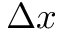<formula> <loc_0><loc_0><loc_500><loc_500>\Delta x</formula> 